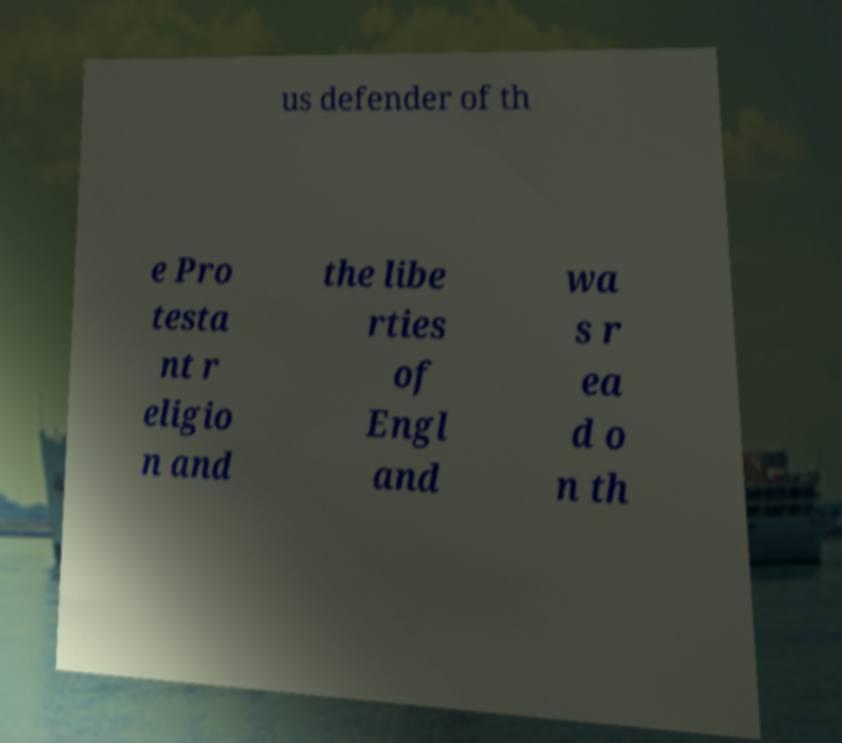There's text embedded in this image that I need extracted. Can you transcribe it verbatim? us defender of th e Pro testa nt r eligio n and the libe rties of Engl and wa s r ea d o n th 